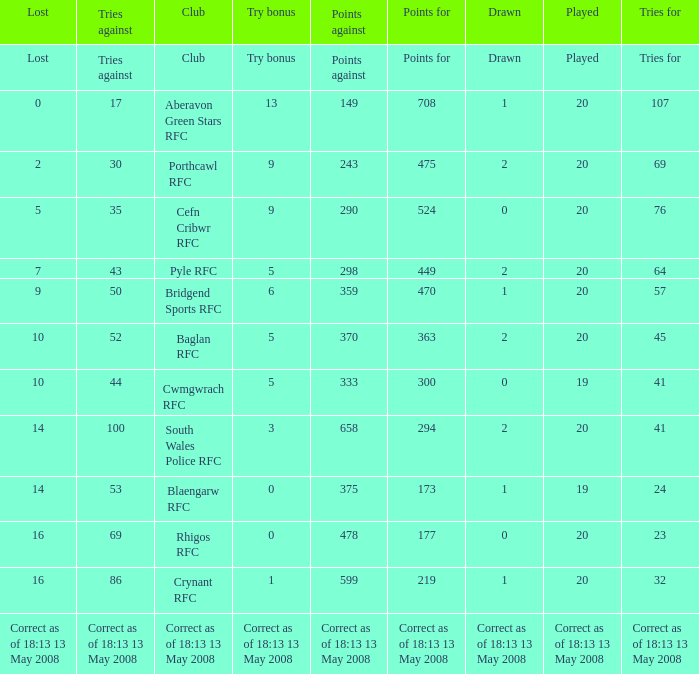What is the points number when 20 shows for played, and lost is 0? 708.0. 